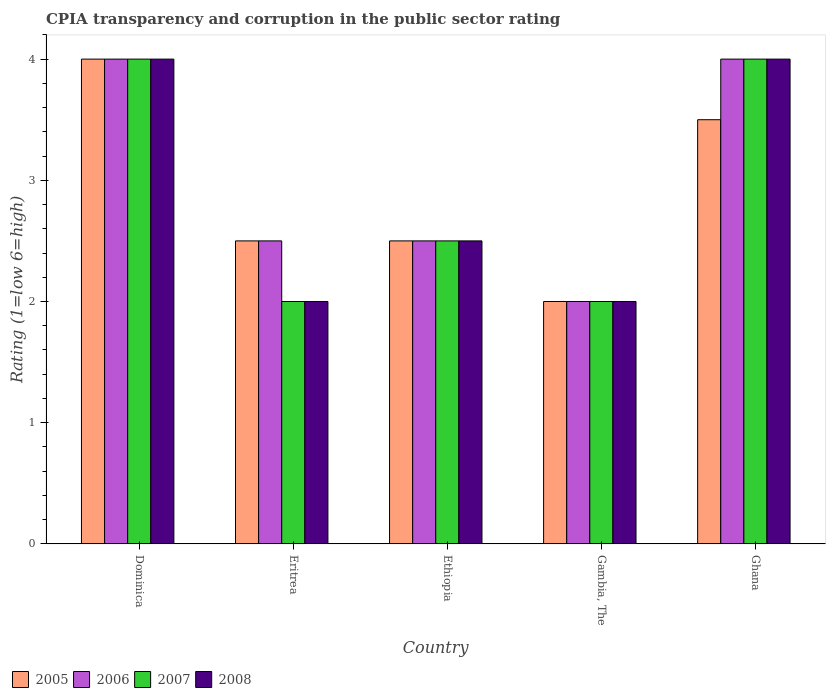How many different coloured bars are there?
Offer a very short reply. 4. How many groups of bars are there?
Your answer should be very brief. 5. Are the number of bars per tick equal to the number of legend labels?
Ensure brevity in your answer.  Yes. Are the number of bars on each tick of the X-axis equal?
Provide a short and direct response. Yes. How many bars are there on the 4th tick from the right?
Offer a terse response. 4. Across all countries, what is the maximum CPIA rating in 2008?
Give a very brief answer. 4. Across all countries, what is the minimum CPIA rating in 2008?
Ensure brevity in your answer.  2. In which country was the CPIA rating in 2008 maximum?
Your response must be concise. Dominica. In which country was the CPIA rating in 2006 minimum?
Offer a very short reply. Gambia, The. What is the total CPIA rating in 2008 in the graph?
Offer a terse response. 14.5. What is the difference between the CPIA rating in 2005 in Dominica and that in Eritrea?
Provide a short and direct response. 1.5. What is the average CPIA rating in 2006 per country?
Provide a succinct answer. 3. In how many countries, is the CPIA rating in 2005 greater than 1.6?
Your answer should be very brief. 5. What is the ratio of the CPIA rating in 2008 in Eritrea to that in Gambia, The?
Offer a very short reply. 1. Is the CPIA rating in 2005 in Gambia, The less than that in Ghana?
Your answer should be compact. Yes. What is the difference between the highest and the second highest CPIA rating in 2008?
Provide a succinct answer. -1.5. What is the difference between the highest and the lowest CPIA rating in 2007?
Provide a succinct answer. 2. In how many countries, is the CPIA rating in 2006 greater than the average CPIA rating in 2006 taken over all countries?
Make the answer very short. 2. What does the 1st bar from the left in Ghana represents?
Provide a succinct answer. 2005. What does the 2nd bar from the right in Eritrea represents?
Your response must be concise. 2007. Are all the bars in the graph horizontal?
Your answer should be compact. No. What is the difference between two consecutive major ticks on the Y-axis?
Provide a short and direct response. 1. Are the values on the major ticks of Y-axis written in scientific E-notation?
Provide a succinct answer. No. Does the graph contain grids?
Offer a terse response. No. Where does the legend appear in the graph?
Your answer should be very brief. Bottom left. What is the title of the graph?
Your answer should be very brief. CPIA transparency and corruption in the public sector rating. Does "1981" appear as one of the legend labels in the graph?
Keep it short and to the point. No. What is the label or title of the X-axis?
Offer a very short reply. Country. What is the label or title of the Y-axis?
Offer a terse response. Rating (1=low 6=high). What is the Rating (1=low 6=high) of 2005 in Dominica?
Your response must be concise. 4. What is the Rating (1=low 6=high) of 2006 in Dominica?
Provide a short and direct response. 4. What is the Rating (1=low 6=high) of 2005 in Ethiopia?
Your answer should be compact. 2.5. What is the Rating (1=low 6=high) in 2006 in Gambia, The?
Ensure brevity in your answer.  2. What is the Rating (1=low 6=high) of 2005 in Ghana?
Offer a terse response. 3.5. What is the Rating (1=low 6=high) in 2006 in Ghana?
Your response must be concise. 4. What is the Rating (1=low 6=high) in 2007 in Ghana?
Provide a succinct answer. 4. What is the Rating (1=low 6=high) of 2008 in Ghana?
Offer a terse response. 4. Across all countries, what is the maximum Rating (1=low 6=high) of 2007?
Give a very brief answer. 4. What is the total Rating (1=low 6=high) in 2006 in the graph?
Ensure brevity in your answer.  15. What is the total Rating (1=low 6=high) of 2007 in the graph?
Provide a succinct answer. 14.5. What is the difference between the Rating (1=low 6=high) of 2006 in Dominica and that in Eritrea?
Provide a short and direct response. 1.5. What is the difference between the Rating (1=low 6=high) of 2007 in Dominica and that in Eritrea?
Your answer should be compact. 2. What is the difference between the Rating (1=low 6=high) of 2008 in Dominica and that in Eritrea?
Offer a terse response. 2. What is the difference between the Rating (1=low 6=high) in 2008 in Dominica and that in Ethiopia?
Keep it short and to the point. 1.5. What is the difference between the Rating (1=low 6=high) of 2006 in Dominica and that in Gambia, The?
Offer a very short reply. 2. What is the difference between the Rating (1=low 6=high) in 2007 in Dominica and that in Gambia, The?
Ensure brevity in your answer.  2. What is the difference between the Rating (1=low 6=high) in 2005 in Dominica and that in Ghana?
Keep it short and to the point. 0.5. What is the difference between the Rating (1=low 6=high) of 2005 in Eritrea and that in Ethiopia?
Your answer should be very brief. 0. What is the difference between the Rating (1=low 6=high) of 2006 in Eritrea and that in Ethiopia?
Make the answer very short. 0. What is the difference between the Rating (1=low 6=high) of 2007 in Eritrea and that in Ethiopia?
Your answer should be compact. -0.5. What is the difference between the Rating (1=low 6=high) in 2005 in Eritrea and that in Gambia, The?
Your answer should be very brief. 0.5. What is the difference between the Rating (1=low 6=high) of 2006 in Eritrea and that in Gambia, The?
Offer a very short reply. 0.5. What is the difference between the Rating (1=low 6=high) of 2007 in Eritrea and that in Gambia, The?
Offer a terse response. 0. What is the difference between the Rating (1=low 6=high) of 2006 in Eritrea and that in Ghana?
Keep it short and to the point. -1.5. What is the difference between the Rating (1=low 6=high) of 2008 in Eritrea and that in Ghana?
Offer a very short reply. -2. What is the difference between the Rating (1=low 6=high) of 2006 in Ethiopia and that in Gambia, The?
Your answer should be very brief. 0.5. What is the difference between the Rating (1=low 6=high) in 2005 in Ethiopia and that in Ghana?
Make the answer very short. -1. What is the difference between the Rating (1=low 6=high) in 2008 in Ethiopia and that in Ghana?
Your response must be concise. -1.5. What is the difference between the Rating (1=low 6=high) in 2006 in Gambia, The and that in Ghana?
Your answer should be very brief. -2. What is the difference between the Rating (1=low 6=high) of 2008 in Gambia, The and that in Ghana?
Your answer should be compact. -2. What is the difference between the Rating (1=low 6=high) of 2005 in Dominica and the Rating (1=low 6=high) of 2006 in Eritrea?
Give a very brief answer. 1.5. What is the difference between the Rating (1=low 6=high) in 2005 in Dominica and the Rating (1=low 6=high) in 2007 in Eritrea?
Offer a very short reply. 2. What is the difference between the Rating (1=low 6=high) of 2006 in Dominica and the Rating (1=low 6=high) of 2007 in Eritrea?
Your answer should be compact. 2. What is the difference between the Rating (1=low 6=high) in 2006 in Dominica and the Rating (1=low 6=high) in 2008 in Eritrea?
Offer a terse response. 2. What is the difference between the Rating (1=low 6=high) of 2007 in Dominica and the Rating (1=low 6=high) of 2008 in Eritrea?
Offer a terse response. 2. What is the difference between the Rating (1=low 6=high) of 2005 in Dominica and the Rating (1=low 6=high) of 2006 in Ethiopia?
Your answer should be very brief. 1.5. What is the difference between the Rating (1=low 6=high) in 2005 in Dominica and the Rating (1=low 6=high) in 2007 in Ethiopia?
Your response must be concise. 1.5. What is the difference between the Rating (1=low 6=high) in 2006 in Dominica and the Rating (1=low 6=high) in 2008 in Ethiopia?
Ensure brevity in your answer.  1.5. What is the difference between the Rating (1=low 6=high) of 2005 in Dominica and the Rating (1=low 6=high) of 2007 in Gambia, The?
Provide a succinct answer. 2. What is the difference between the Rating (1=low 6=high) of 2005 in Dominica and the Rating (1=low 6=high) of 2007 in Ghana?
Offer a terse response. 0. What is the difference between the Rating (1=low 6=high) of 2006 in Dominica and the Rating (1=low 6=high) of 2007 in Ghana?
Keep it short and to the point. 0. What is the difference between the Rating (1=low 6=high) in 2007 in Dominica and the Rating (1=low 6=high) in 2008 in Ghana?
Keep it short and to the point. 0. What is the difference between the Rating (1=low 6=high) in 2005 in Eritrea and the Rating (1=low 6=high) in 2007 in Ethiopia?
Provide a succinct answer. 0. What is the difference between the Rating (1=low 6=high) of 2005 in Eritrea and the Rating (1=low 6=high) of 2008 in Ethiopia?
Provide a succinct answer. 0. What is the difference between the Rating (1=low 6=high) of 2006 in Eritrea and the Rating (1=low 6=high) of 2007 in Ethiopia?
Keep it short and to the point. 0. What is the difference between the Rating (1=low 6=high) in 2006 in Eritrea and the Rating (1=low 6=high) in 2008 in Ethiopia?
Your answer should be very brief. 0. What is the difference between the Rating (1=low 6=high) in 2005 in Eritrea and the Rating (1=low 6=high) in 2007 in Gambia, The?
Your answer should be compact. 0.5. What is the difference between the Rating (1=low 6=high) in 2005 in Eritrea and the Rating (1=low 6=high) in 2008 in Gambia, The?
Provide a short and direct response. 0.5. What is the difference between the Rating (1=low 6=high) in 2006 in Eritrea and the Rating (1=low 6=high) in 2007 in Gambia, The?
Provide a succinct answer. 0.5. What is the difference between the Rating (1=low 6=high) of 2005 in Eritrea and the Rating (1=low 6=high) of 2006 in Ghana?
Your answer should be compact. -1.5. What is the difference between the Rating (1=low 6=high) of 2005 in Eritrea and the Rating (1=low 6=high) of 2007 in Ghana?
Give a very brief answer. -1.5. What is the difference between the Rating (1=low 6=high) of 2005 in Eritrea and the Rating (1=low 6=high) of 2008 in Ghana?
Give a very brief answer. -1.5. What is the difference between the Rating (1=low 6=high) in 2006 in Eritrea and the Rating (1=low 6=high) in 2007 in Ghana?
Give a very brief answer. -1.5. What is the difference between the Rating (1=low 6=high) in 2005 in Ethiopia and the Rating (1=low 6=high) in 2006 in Gambia, The?
Your response must be concise. 0.5. What is the difference between the Rating (1=low 6=high) of 2005 in Ethiopia and the Rating (1=low 6=high) of 2007 in Gambia, The?
Your response must be concise. 0.5. What is the difference between the Rating (1=low 6=high) in 2005 in Ethiopia and the Rating (1=low 6=high) in 2008 in Gambia, The?
Give a very brief answer. 0.5. What is the difference between the Rating (1=low 6=high) in 2006 in Ethiopia and the Rating (1=low 6=high) in 2008 in Gambia, The?
Your response must be concise. 0.5. What is the difference between the Rating (1=low 6=high) in 2005 in Ethiopia and the Rating (1=low 6=high) in 2006 in Ghana?
Your answer should be very brief. -1.5. What is the difference between the Rating (1=low 6=high) of 2006 in Ethiopia and the Rating (1=low 6=high) of 2007 in Ghana?
Your response must be concise. -1.5. What is the difference between the Rating (1=low 6=high) in 2007 in Ethiopia and the Rating (1=low 6=high) in 2008 in Ghana?
Your response must be concise. -1.5. What is the difference between the Rating (1=low 6=high) in 2005 in Gambia, The and the Rating (1=low 6=high) in 2006 in Ghana?
Provide a short and direct response. -2. What is the difference between the Rating (1=low 6=high) in 2006 in Gambia, The and the Rating (1=low 6=high) in 2007 in Ghana?
Your response must be concise. -2. What is the difference between the Rating (1=low 6=high) in 2007 in Gambia, The and the Rating (1=low 6=high) in 2008 in Ghana?
Your answer should be very brief. -2. What is the difference between the Rating (1=low 6=high) of 2005 and Rating (1=low 6=high) of 2006 in Dominica?
Give a very brief answer. 0. What is the difference between the Rating (1=low 6=high) in 2005 and Rating (1=low 6=high) in 2007 in Dominica?
Your response must be concise. 0. What is the difference between the Rating (1=low 6=high) in 2005 and Rating (1=low 6=high) in 2008 in Dominica?
Keep it short and to the point. 0. What is the difference between the Rating (1=low 6=high) in 2005 and Rating (1=low 6=high) in 2006 in Eritrea?
Your response must be concise. 0. What is the difference between the Rating (1=low 6=high) of 2005 and Rating (1=low 6=high) of 2006 in Ethiopia?
Keep it short and to the point. 0. What is the difference between the Rating (1=low 6=high) of 2005 and Rating (1=low 6=high) of 2007 in Ethiopia?
Make the answer very short. 0. What is the difference between the Rating (1=low 6=high) of 2006 and Rating (1=low 6=high) of 2008 in Ethiopia?
Your answer should be compact. 0. What is the difference between the Rating (1=low 6=high) of 2005 and Rating (1=low 6=high) of 2007 in Gambia, The?
Provide a short and direct response. 0. What is the difference between the Rating (1=low 6=high) in 2006 and Rating (1=low 6=high) in 2007 in Gambia, The?
Provide a succinct answer. 0. What is the difference between the Rating (1=low 6=high) in 2006 and Rating (1=low 6=high) in 2008 in Gambia, The?
Provide a short and direct response. 0. What is the difference between the Rating (1=low 6=high) in 2007 and Rating (1=low 6=high) in 2008 in Gambia, The?
Ensure brevity in your answer.  0. What is the difference between the Rating (1=low 6=high) of 2005 and Rating (1=low 6=high) of 2006 in Ghana?
Your answer should be very brief. -0.5. What is the difference between the Rating (1=low 6=high) of 2006 and Rating (1=low 6=high) of 2008 in Ghana?
Provide a short and direct response. 0. What is the ratio of the Rating (1=low 6=high) in 2006 in Dominica to that in Eritrea?
Your answer should be compact. 1.6. What is the ratio of the Rating (1=low 6=high) in 2005 in Dominica to that in Ethiopia?
Offer a very short reply. 1.6. What is the ratio of the Rating (1=low 6=high) of 2005 in Dominica to that in Gambia, The?
Your answer should be very brief. 2. What is the ratio of the Rating (1=low 6=high) in 2007 in Dominica to that in Gambia, The?
Offer a terse response. 2. What is the ratio of the Rating (1=low 6=high) in 2005 in Dominica to that in Ghana?
Your answer should be compact. 1.14. What is the ratio of the Rating (1=low 6=high) in 2007 in Dominica to that in Ghana?
Keep it short and to the point. 1. What is the ratio of the Rating (1=low 6=high) in 2005 in Eritrea to that in Ethiopia?
Make the answer very short. 1. What is the ratio of the Rating (1=low 6=high) of 2008 in Eritrea to that in Ethiopia?
Your response must be concise. 0.8. What is the ratio of the Rating (1=low 6=high) of 2007 in Eritrea to that in Gambia, The?
Your response must be concise. 1. What is the ratio of the Rating (1=low 6=high) in 2008 in Eritrea to that in Gambia, The?
Offer a very short reply. 1. What is the ratio of the Rating (1=low 6=high) of 2005 in Eritrea to that in Ghana?
Keep it short and to the point. 0.71. What is the ratio of the Rating (1=low 6=high) in 2007 in Eritrea to that in Ghana?
Make the answer very short. 0.5. What is the ratio of the Rating (1=low 6=high) of 2008 in Ethiopia to that in Gambia, The?
Your answer should be very brief. 1.25. What is the ratio of the Rating (1=low 6=high) in 2008 in Ethiopia to that in Ghana?
Make the answer very short. 0.62. What is the ratio of the Rating (1=low 6=high) of 2007 in Gambia, The to that in Ghana?
Your answer should be very brief. 0.5. What is the difference between the highest and the second highest Rating (1=low 6=high) of 2005?
Your answer should be compact. 0.5. What is the difference between the highest and the second highest Rating (1=low 6=high) in 2006?
Your answer should be very brief. 0. What is the difference between the highest and the second highest Rating (1=low 6=high) in 2007?
Make the answer very short. 0. What is the difference between the highest and the lowest Rating (1=low 6=high) of 2005?
Provide a short and direct response. 2. What is the difference between the highest and the lowest Rating (1=low 6=high) in 2006?
Your answer should be compact. 2. What is the difference between the highest and the lowest Rating (1=low 6=high) of 2008?
Offer a very short reply. 2. 